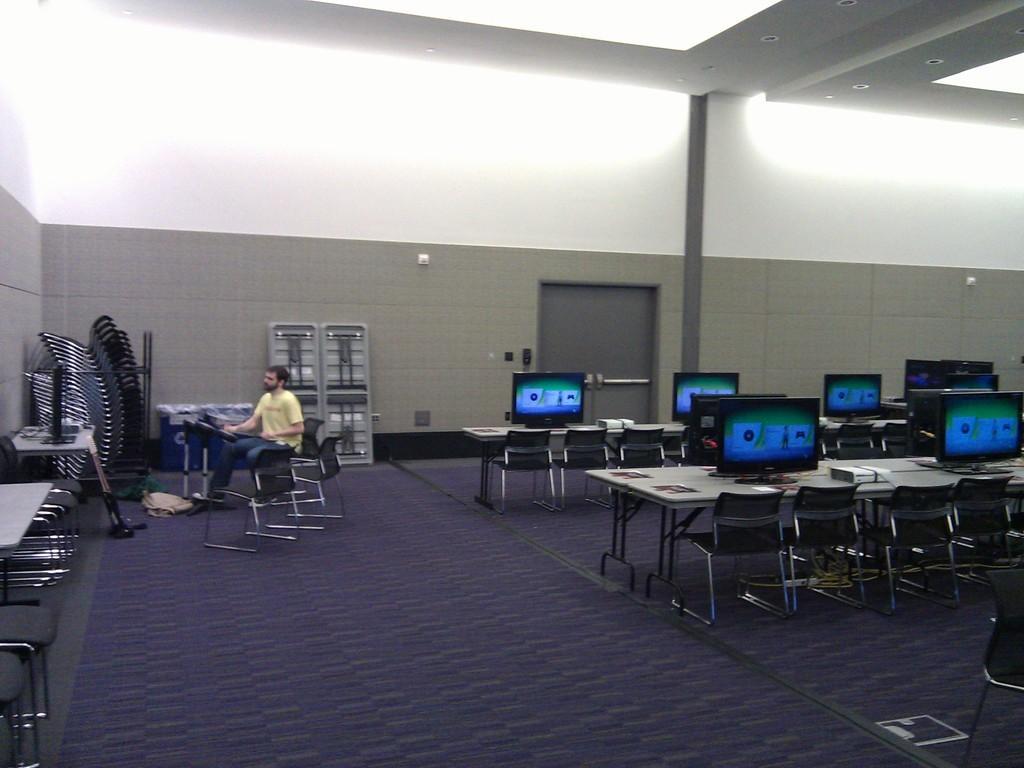In one or two sentences, can you explain what this image depicts? In this image I can see a table,chair,system and the man is sitting on the chair. 